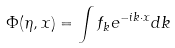Convert formula to latex. <formula><loc_0><loc_0><loc_500><loc_500>\Phi ( \eta , { x } ) = \int f _ { k } e ^ { - i { k \cdot x } } d { k }</formula> 